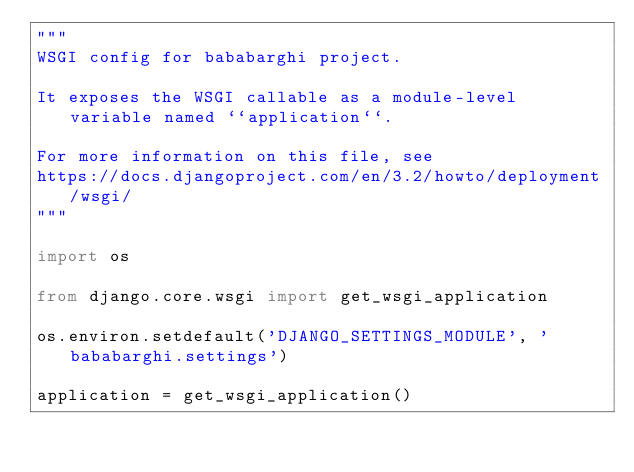<code> <loc_0><loc_0><loc_500><loc_500><_Python_>"""
WSGI config for bababarghi project.

It exposes the WSGI callable as a module-level variable named ``application``.

For more information on this file, see
https://docs.djangoproject.com/en/3.2/howto/deployment/wsgi/
"""

import os

from django.core.wsgi import get_wsgi_application

os.environ.setdefault('DJANGO_SETTINGS_MODULE', 'bababarghi.settings')

application = get_wsgi_application()
</code> 